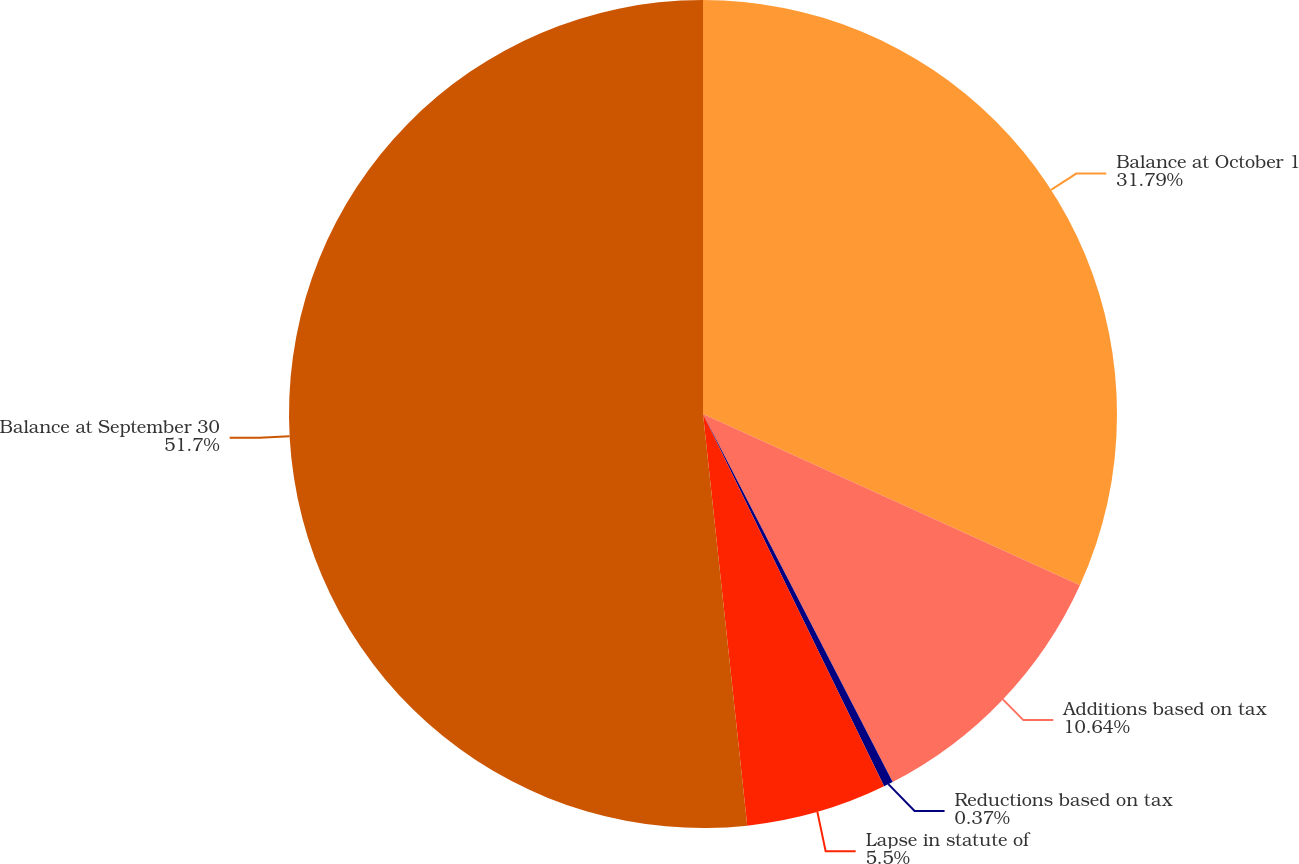Convert chart. <chart><loc_0><loc_0><loc_500><loc_500><pie_chart><fcel>Balance at October 1<fcel>Additions based on tax<fcel>Reductions based on tax<fcel>Lapse in statute of<fcel>Balance at September 30<nl><fcel>31.79%<fcel>10.64%<fcel>0.37%<fcel>5.5%<fcel>51.71%<nl></chart> 